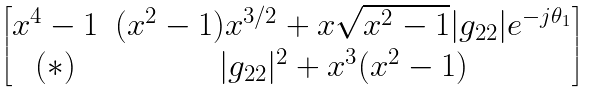Convert formula to latex. <formula><loc_0><loc_0><loc_500><loc_500>\begin{bmatrix} x ^ { 4 } - 1 & ( x ^ { 2 } - 1 ) x ^ { 3 / 2 } + x \sqrt { x ^ { 2 } - 1 } | g _ { 2 2 } | e ^ { - j \theta _ { 1 } } \\ ( \ast ) & | g _ { 2 2 } | ^ { 2 } + x ^ { 3 } ( x ^ { 2 } - 1 ) \end{bmatrix}</formula> 